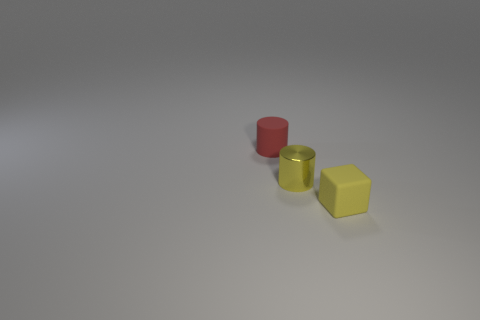Add 3 blue cylinders. How many objects exist? 6 Subtract all cubes. How many objects are left? 2 Subtract 0 cyan cylinders. How many objects are left? 3 Subtract all brown cubes. Subtract all red rubber cylinders. How many objects are left? 2 Add 2 red cylinders. How many red cylinders are left? 3 Add 2 brown metallic cylinders. How many brown metallic cylinders exist? 2 